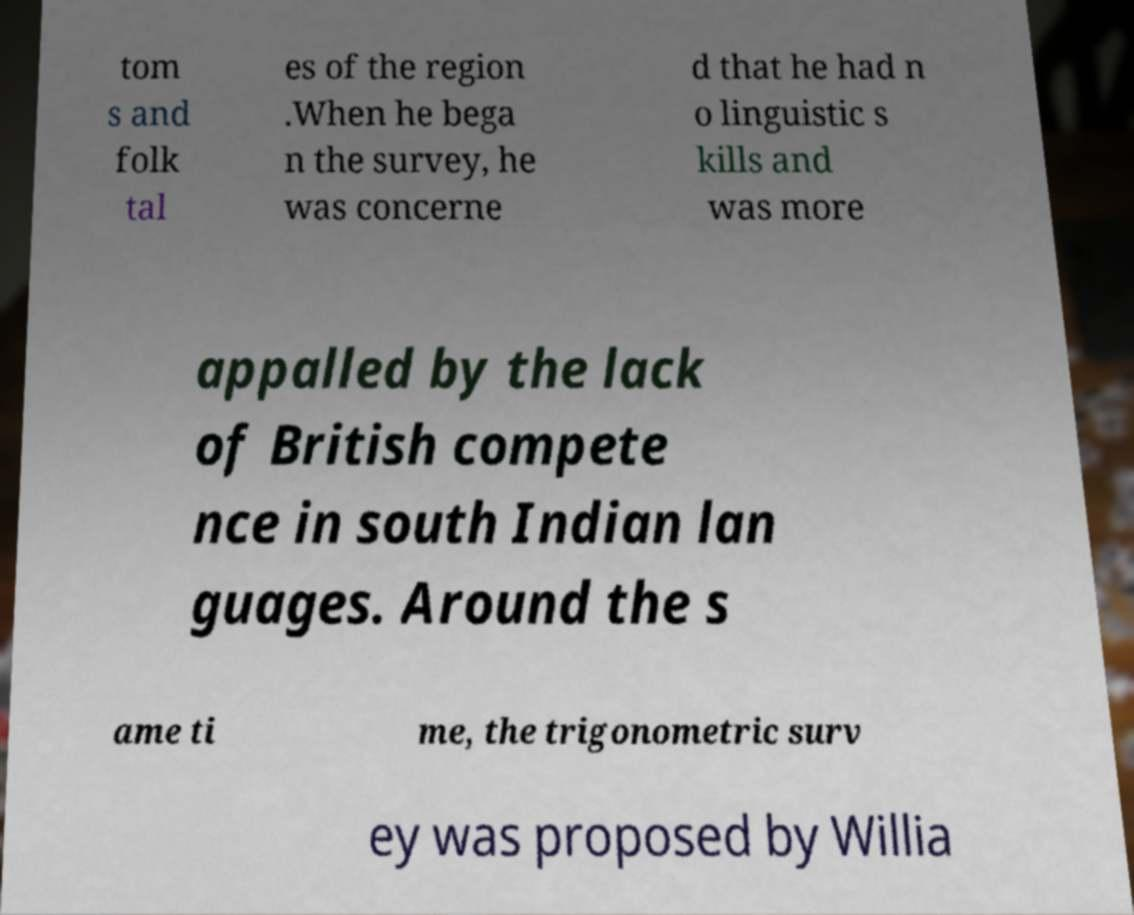I need the written content from this picture converted into text. Can you do that? tom s and folk tal es of the region .When he bega n the survey, he was concerne d that he had n o linguistic s kills and was more appalled by the lack of British compete nce in south Indian lan guages. Around the s ame ti me, the trigonometric surv ey was proposed by Willia 